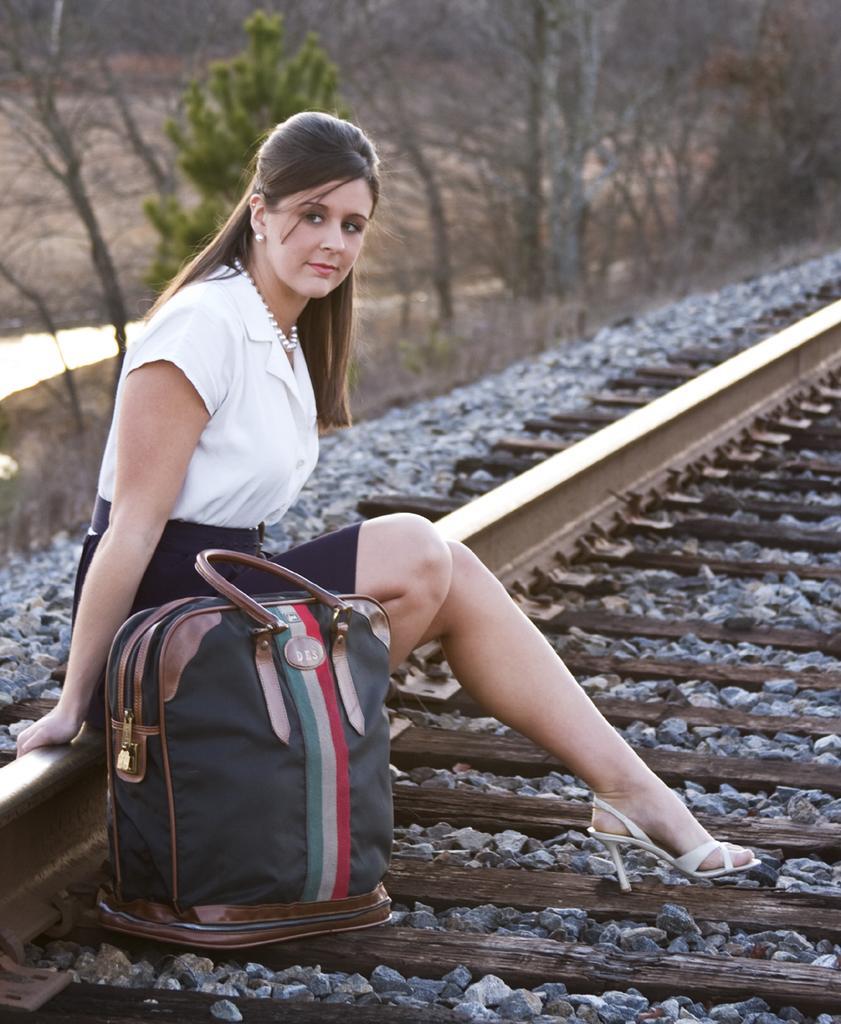Can you describe this image briefly? On the background we can see bare trees and a cactus plant. Here we can see a women sitting on a railway track and there is a handbag beside her. She wore pearl earrings and a necklace. 